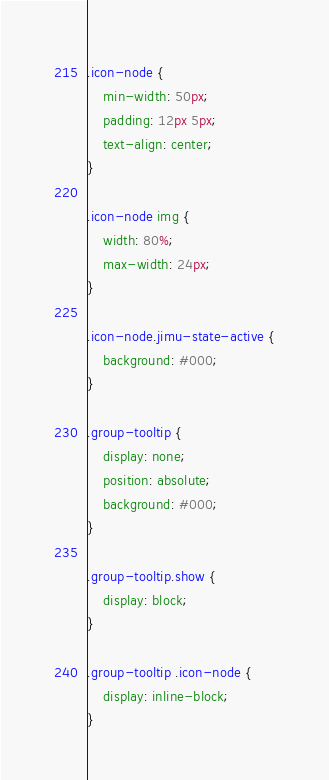<code> <loc_0><loc_0><loc_500><loc_500><_CSS_>.icon-node {
    min-width: 50px;
    padding: 12px 5px;
    text-align: center;
}

.icon-node img {
    width: 80%;
    max-width: 24px;
}

.icon-node.jimu-state-active {
    background: #000;
}

.group-tooltip {
    display: none;
    position: absolute;
    background: #000;
}

.group-tooltip.show {
    display: block;
}

.group-tooltip .icon-node {
    display: inline-block;
}</code> 